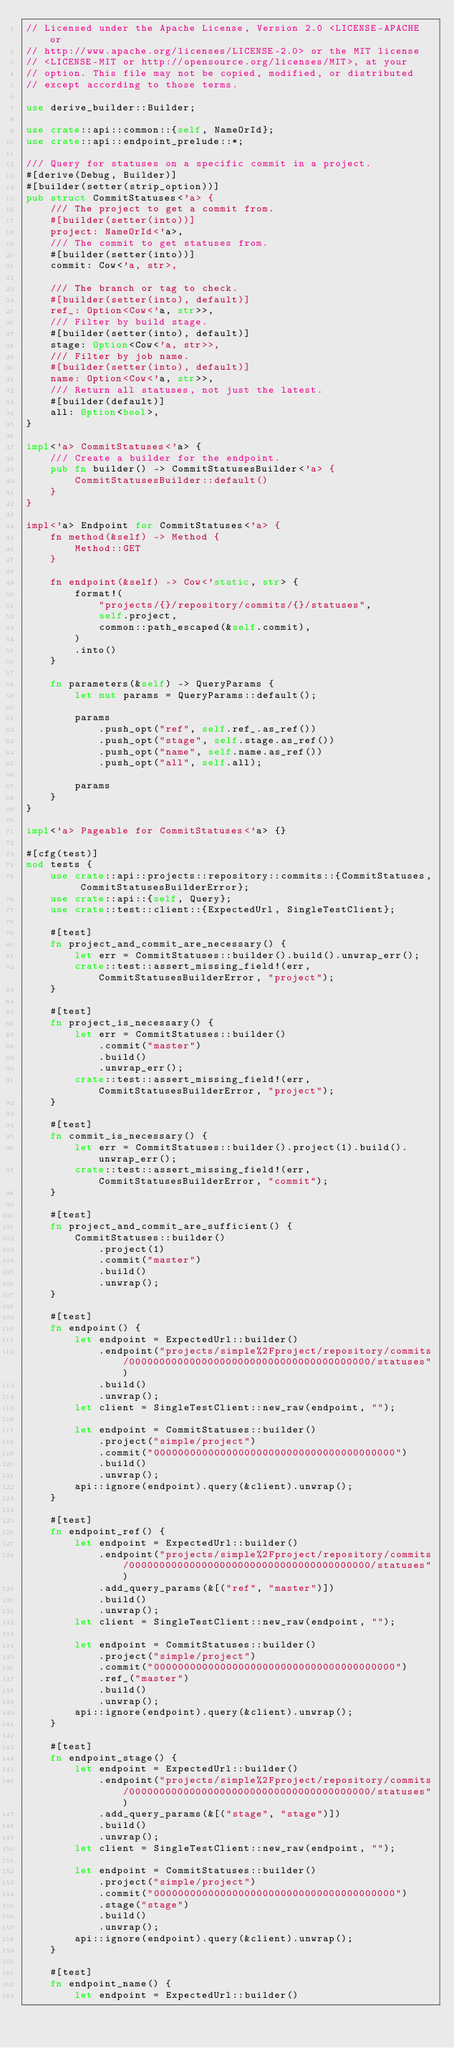Convert code to text. <code><loc_0><loc_0><loc_500><loc_500><_Rust_>// Licensed under the Apache License, Version 2.0 <LICENSE-APACHE or
// http://www.apache.org/licenses/LICENSE-2.0> or the MIT license
// <LICENSE-MIT or http://opensource.org/licenses/MIT>, at your
// option. This file may not be copied, modified, or distributed
// except according to those terms.

use derive_builder::Builder;

use crate::api::common::{self, NameOrId};
use crate::api::endpoint_prelude::*;

/// Query for statuses on a specific commit in a project.
#[derive(Debug, Builder)]
#[builder(setter(strip_option))]
pub struct CommitStatuses<'a> {
    /// The project to get a commit from.
    #[builder(setter(into))]
    project: NameOrId<'a>,
    /// The commit to get statuses from.
    #[builder(setter(into))]
    commit: Cow<'a, str>,

    /// The branch or tag to check.
    #[builder(setter(into), default)]
    ref_: Option<Cow<'a, str>>,
    /// Filter by build stage.
    #[builder(setter(into), default)]
    stage: Option<Cow<'a, str>>,
    /// Filter by job name.
    #[builder(setter(into), default)]
    name: Option<Cow<'a, str>>,
    /// Return all statuses, not just the latest.
    #[builder(default)]
    all: Option<bool>,
}

impl<'a> CommitStatuses<'a> {
    /// Create a builder for the endpoint.
    pub fn builder() -> CommitStatusesBuilder<'a> {
        CommitStatusesBuilder::default()
    }
}

impl<'a> Endpoint for CommitStatuses<'a> {
    fn method(&self) -> Method {
        Method::GET
    }

    fn endpoint(&self) -> Cow<'static, str> {
        format!(
            "projects/{}/repository/commits/{}/statuses",
            self.project,
            common::path_escaped(&self.commit),
        )
        .into()
    }

    fn parameters(&self) -> QueryParams {
        let mut params = QueryParams::default();

        params
            .push_opt("ref", self.ref_.as_ref())
            .push_opt("stage", self.stage.as_ref())
            .push_opt("name", self.name.as_ref())
            .push_opt("all", self.all);

        params
    }
}

impl<'a> Pageable for CommitStatuses<'a> {}

#[cfg(test)]
mod tests {
    use crate::api::projects::repository::commits::{CommitStatuses, CommitStatusesBuilderError};
    use crate::api::{self, Query};
    use crate::test::client::{ExpectedUrl, SingleTestClient};

    #[test]
    fn project_and_commit_are_necessary() {
        let err = CommitStatuses::builder().build().unwrap_err();
        crate::test::assert_missing_field!(err, CommitStatusesBuilderError, "project");
    }

    #[test]
    fn project_is_necessary() {
        let err = CommitStatuses::builder()
            .commit("master")
            .build()
            .unwrap_err();
        crate::test::assert_missing_field!(err, CommitStatusesBuilderError, "project");
    }

    #[test]
    fn commit_is_necessary() {
        let err = CommitStatuses::builder().project(1).build().unwrap_err();
        crate::test::assert_missing_field!(err, CommitStatusesBuilderError, "commit");
    }

    #[test]
    fn project_and_commit_are_sufficient() {
        CommitStatuses::builder()
            .project(1)
            .commit("master")
            .build()
            .unwrap();
    }

    #[test]
    fn endpoint() {
        let endpoint = ExpectedUrl::builder()
            .endpoint("projects/simple%2Fproject/repository/commits/0000000000000000000000000000000000000000/statuses")
            .build()
            .unwrap();
        let client = SingleTestClient::new_raw(endpoint, "");

        let endpoint = CommitStatuses::builder()
            .project("simple/project")
            .commit("0000000000000000000000000000000000000000")
            .build()
            .unwrap();
        api::ignore(endpoint).query(&client).unwrap();
    }

    #[test]
    fn endpoint_ref() {
        let endpoint = ExpectedUrl::builder()
            .endpoint("projects/simple%2Fproject/repository/commits/0000000000000000000000000000000000000000/statuses")
            .add_query_params(&[("ref", "master")])
            .build()
            .unwrap();
        let client = SingleTestClient::new_raw(endpoint, "");

        let endpoint = CommitStatuses::builder()
            .project("simple/project")
            .commit("0000000000000000000000000000000000000000")
            .ref_("master")
            .build()
            .unwrap();
        api::ignore(endpoint).query(&client).unwrap();
    }

    #[test]
    fn endpoint_stage() {
        let endpoint = ExpectedUrl::builder()
            .endpoint("projects/simple%2Fproject/repository/commits/0000000000000000000000000000000000000000/statuses")
            .add_query_params(&[("stage", "stage")])
            .build()
            .unwrap();
        let client = SingleTestClient::new_raw(endpoint, "");

        let endpoint = CommitStatuses::builder()
            .project("simple/project")
            .commit("0000000000000000000000000000000000000000")
            .stage("stage")
            .build()
            .unwrap();
        api::ignore(endpoint).query(&client).unwrap();
    }

    #[test]
    fn endpoint_name() {
        let endpoint = ExpectedUrl::builder()</code> 